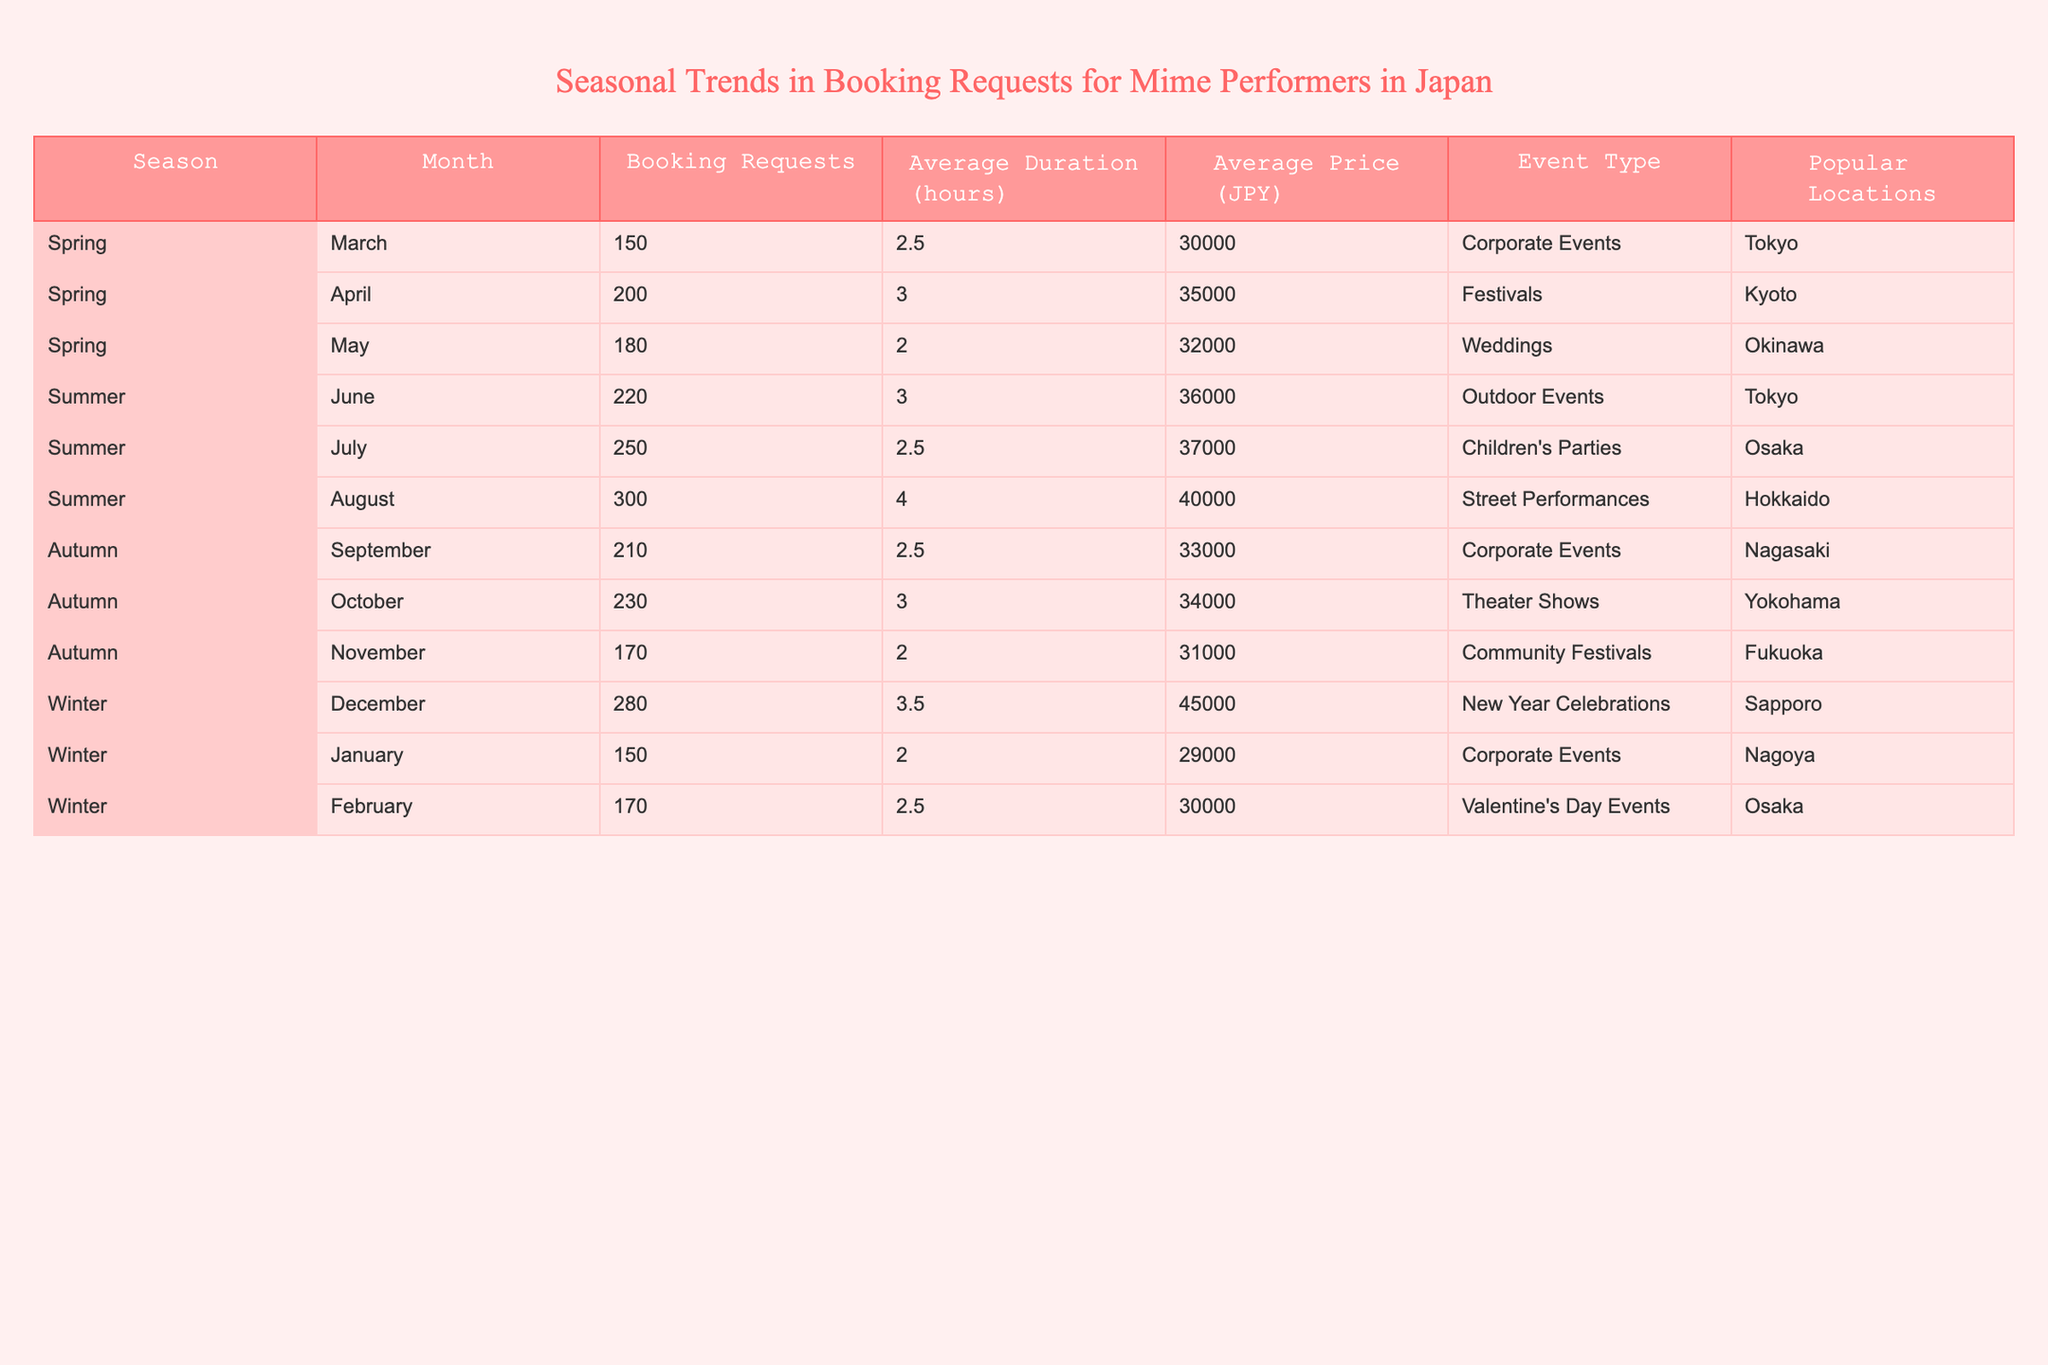What is the average price for booking requests in summer? In summer, there are three months: June, July, and August. The prices for these months are 36000, 37000, and 40000 JPY, respectively. To find the average, we add these values: (36000 + 37000 + 40000) = 113000. We then divide by the number of months (3), giving us 113000 / 3 = 37666.67. Rounding to the nearest whole number, the average price is 37667.
Answer: 37667 Which month had the highest number of booking requests? By checking the "Booking Requests" column, we can see that August has the highest requests with 300.
Answer: August Are corporate events more popular in autumn than in winter? In autumn, there are two months with corporate events (September and November) with 210 and 170 bookings, respectively. In winter, there are two months with corporate events (December and January) with 280 and 150 bookings, respectively. Total bookings for autumn = 210 + 170 = 380, and for winter = 280 + 150 = 430. Since 380 is less than 430, corporate events are not more popular in autumn than in winter.
Answer: No What is the total number of booking requests across all seasons? To find the total, we need to add the number of booking requests for every month: 150 + 200 + 180 + 220 + 250 + 300 + 210 + 230 + 170 + 280 + 150 + 170 = 2410.
Answer: 2410 Was there a month in winter where the average duration was over 3 hours? Inspecting the "Average Duration" column for winter, December has an average duration of 3.5 hours, which is over 3 hours. January has 2 hours, and February has 2.5 hours. Since December is over 3 hours, the answer is yes.
Answer: Yes 